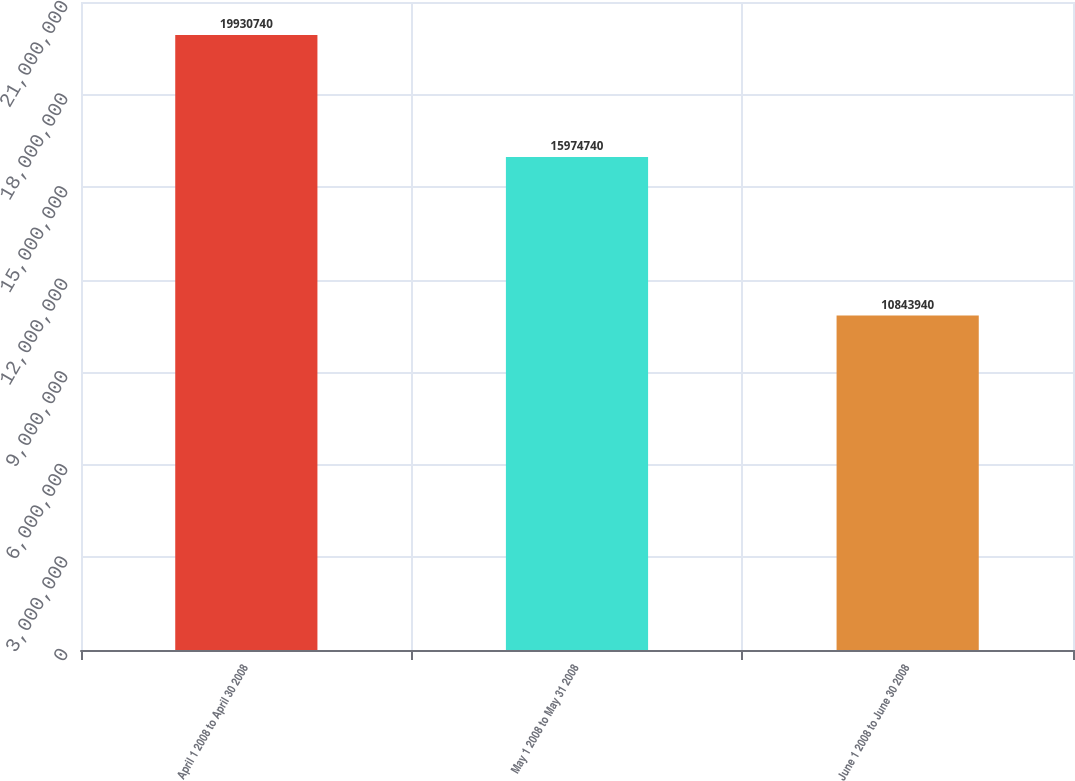Convert chart to OTSL. <chart><loc_0><loc_0><loc_500><loc_500><bar_chart><fcel>April 1 2008 to April 30 2008<fcel>May 1 2008 to May 31 2008<fcel>June 1 2008 to June 30 2008<nl><fcel>1.99307e+07<fcel>1.59747e+07<fcel>1.08439e+07<nl></chart> 